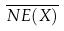<formula> <loc_0><loc_0><loc_500><loc_500>\overline { N E ( X ) }</formula> 